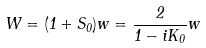Convert formula to latex. <formula><loc_0><loc_0><loc_500><loc_500>W = ( 1 + S _ { 0 } ) w = \frac { 2 } { 1 - i K _ { 0 } } w</formula> 